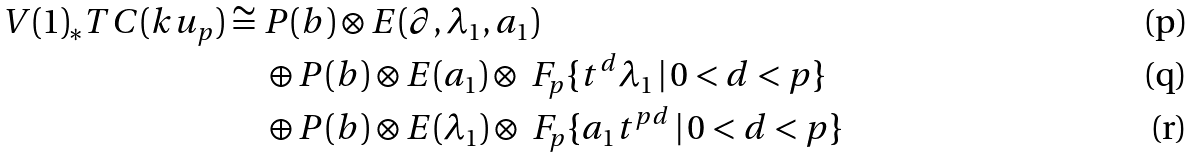<formula> <loc_0><loc_0><loc_500><loc_500>V ( 1 ) _ { * } T C ( k u _ { p } ) \cong \ & P ( b ) \otimes E ( \partial , \lambda _ { 1 } , a _ { 1 } ) \\ & \oplus P ( b ) \otimes E ( a _ { 1 } ) \otimes \ F _ { p } \{ t ^ { d } \lambda _ { 1 } \, | \, 0 < d < p \} \\ & \oplus P ( b ) \otimes E ( \lambda _ { 1 } ) \otimes \ F _ { p } \{ a _ { 1 } t ^ { p d } \, | \, 0 < d < p \}</formula> 